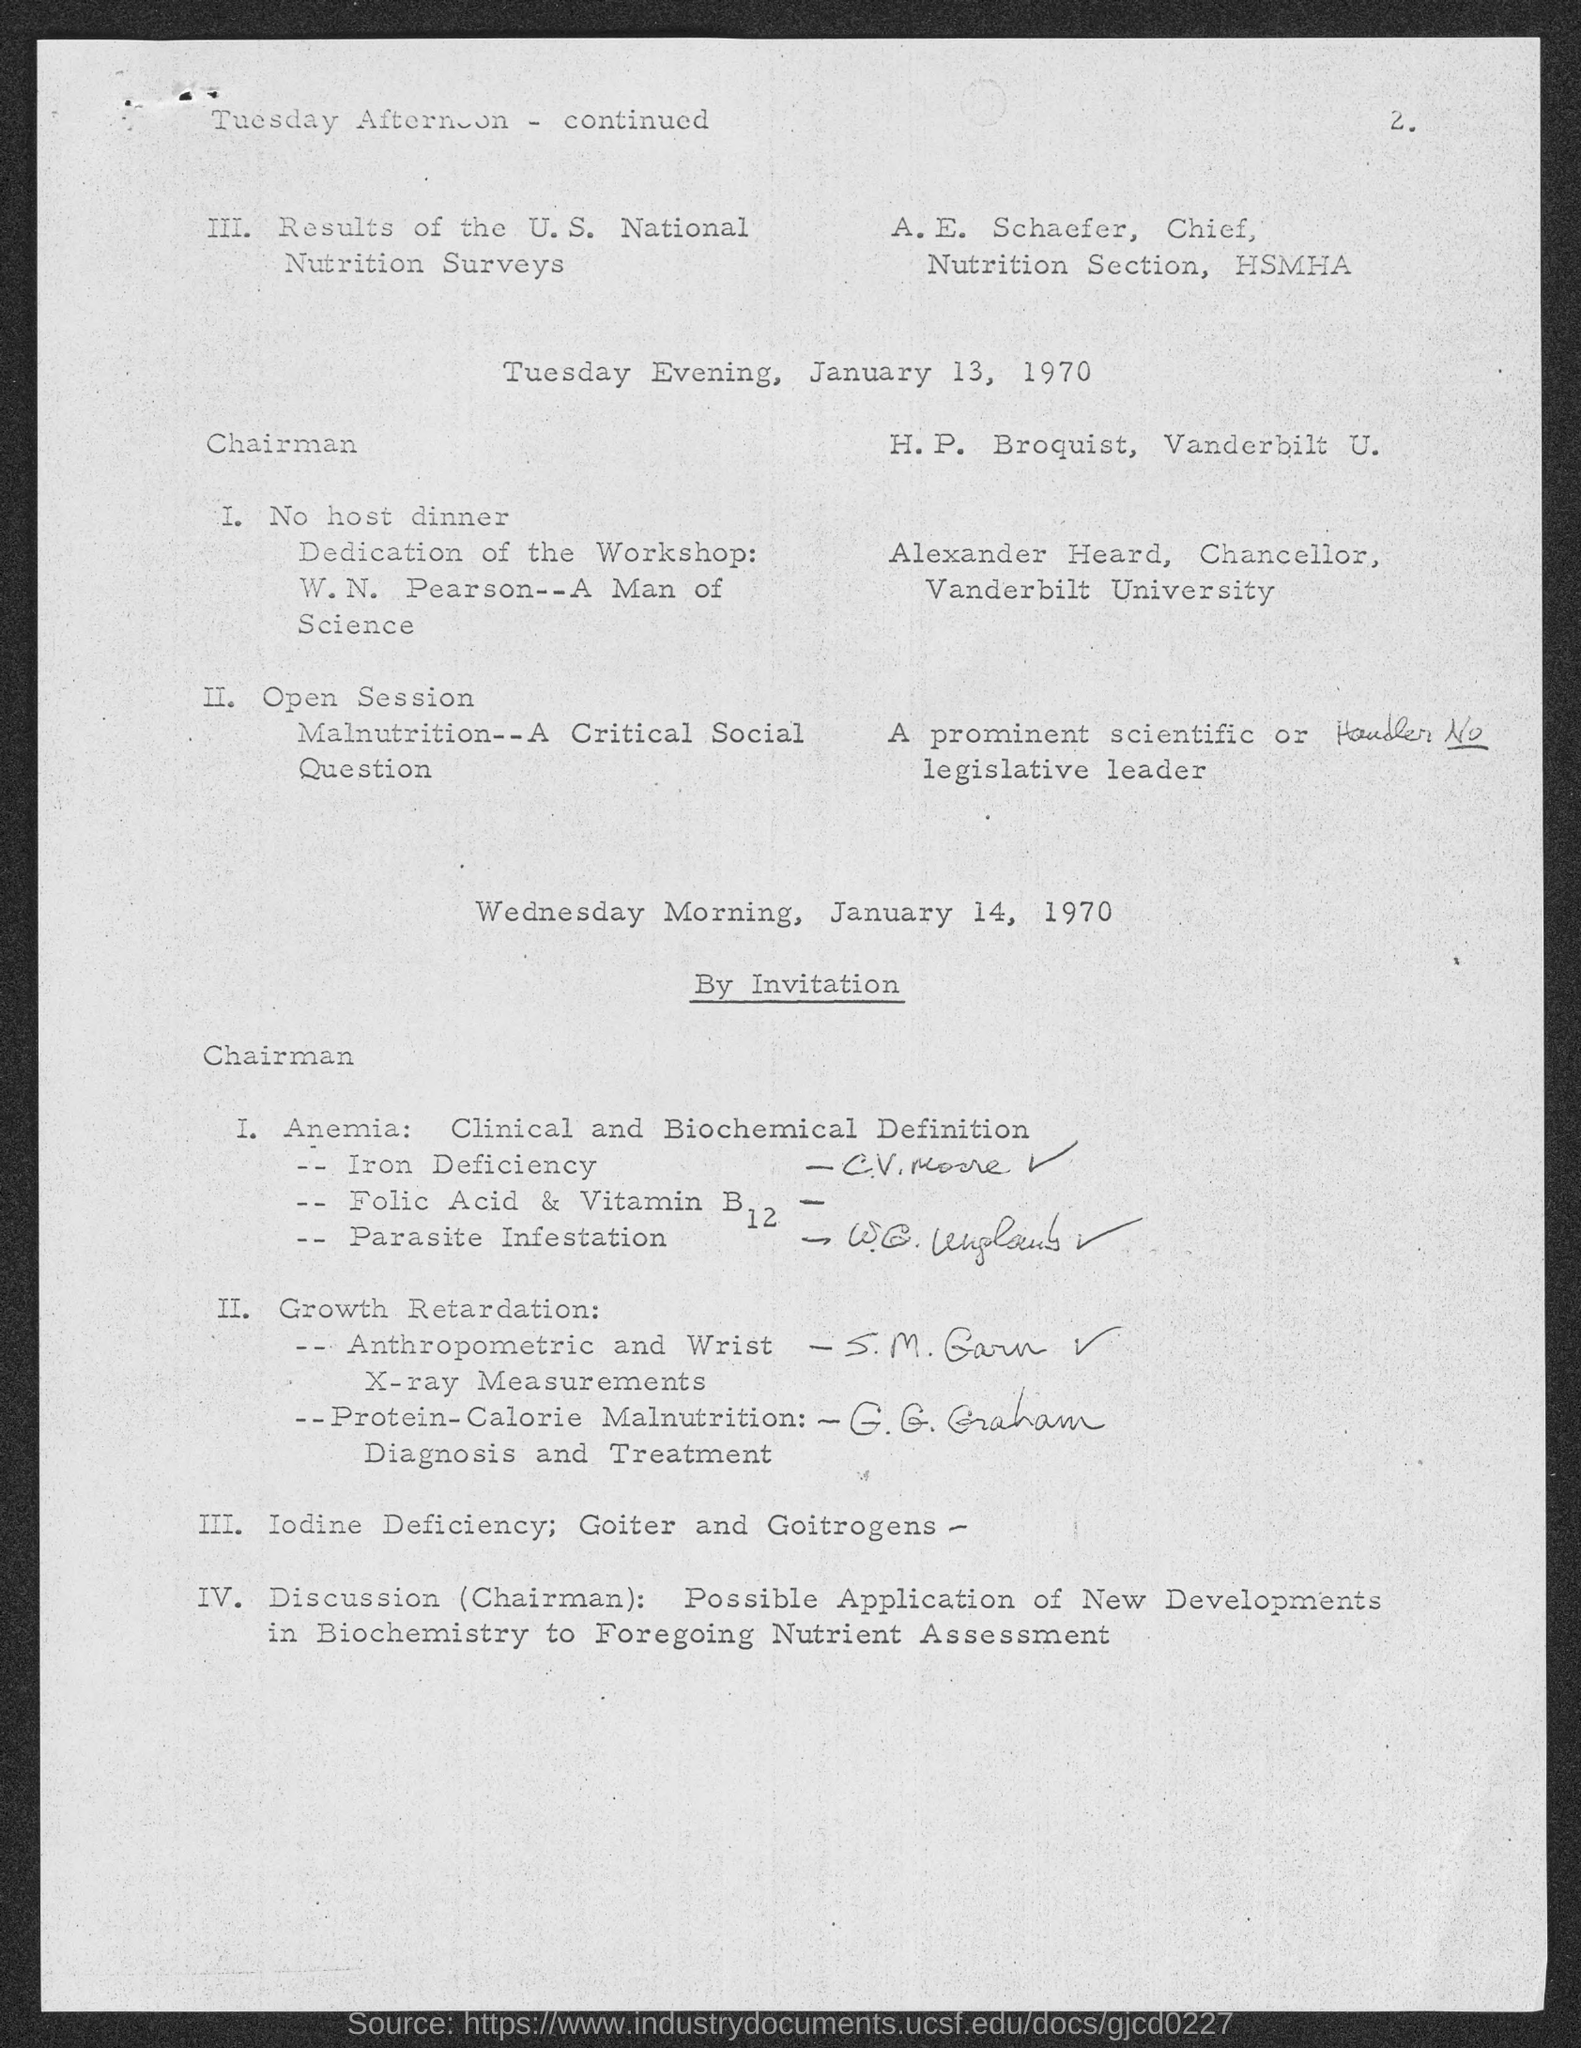What is the page number?
Your response must be concise. 2. Who is the chief of the nutrition section at HSMHA?
Your answer should be very brief. A.e. schaefer. Who is the chancellor of Vanderbilt University?
Your answer should be very brief. Alexander heard. 